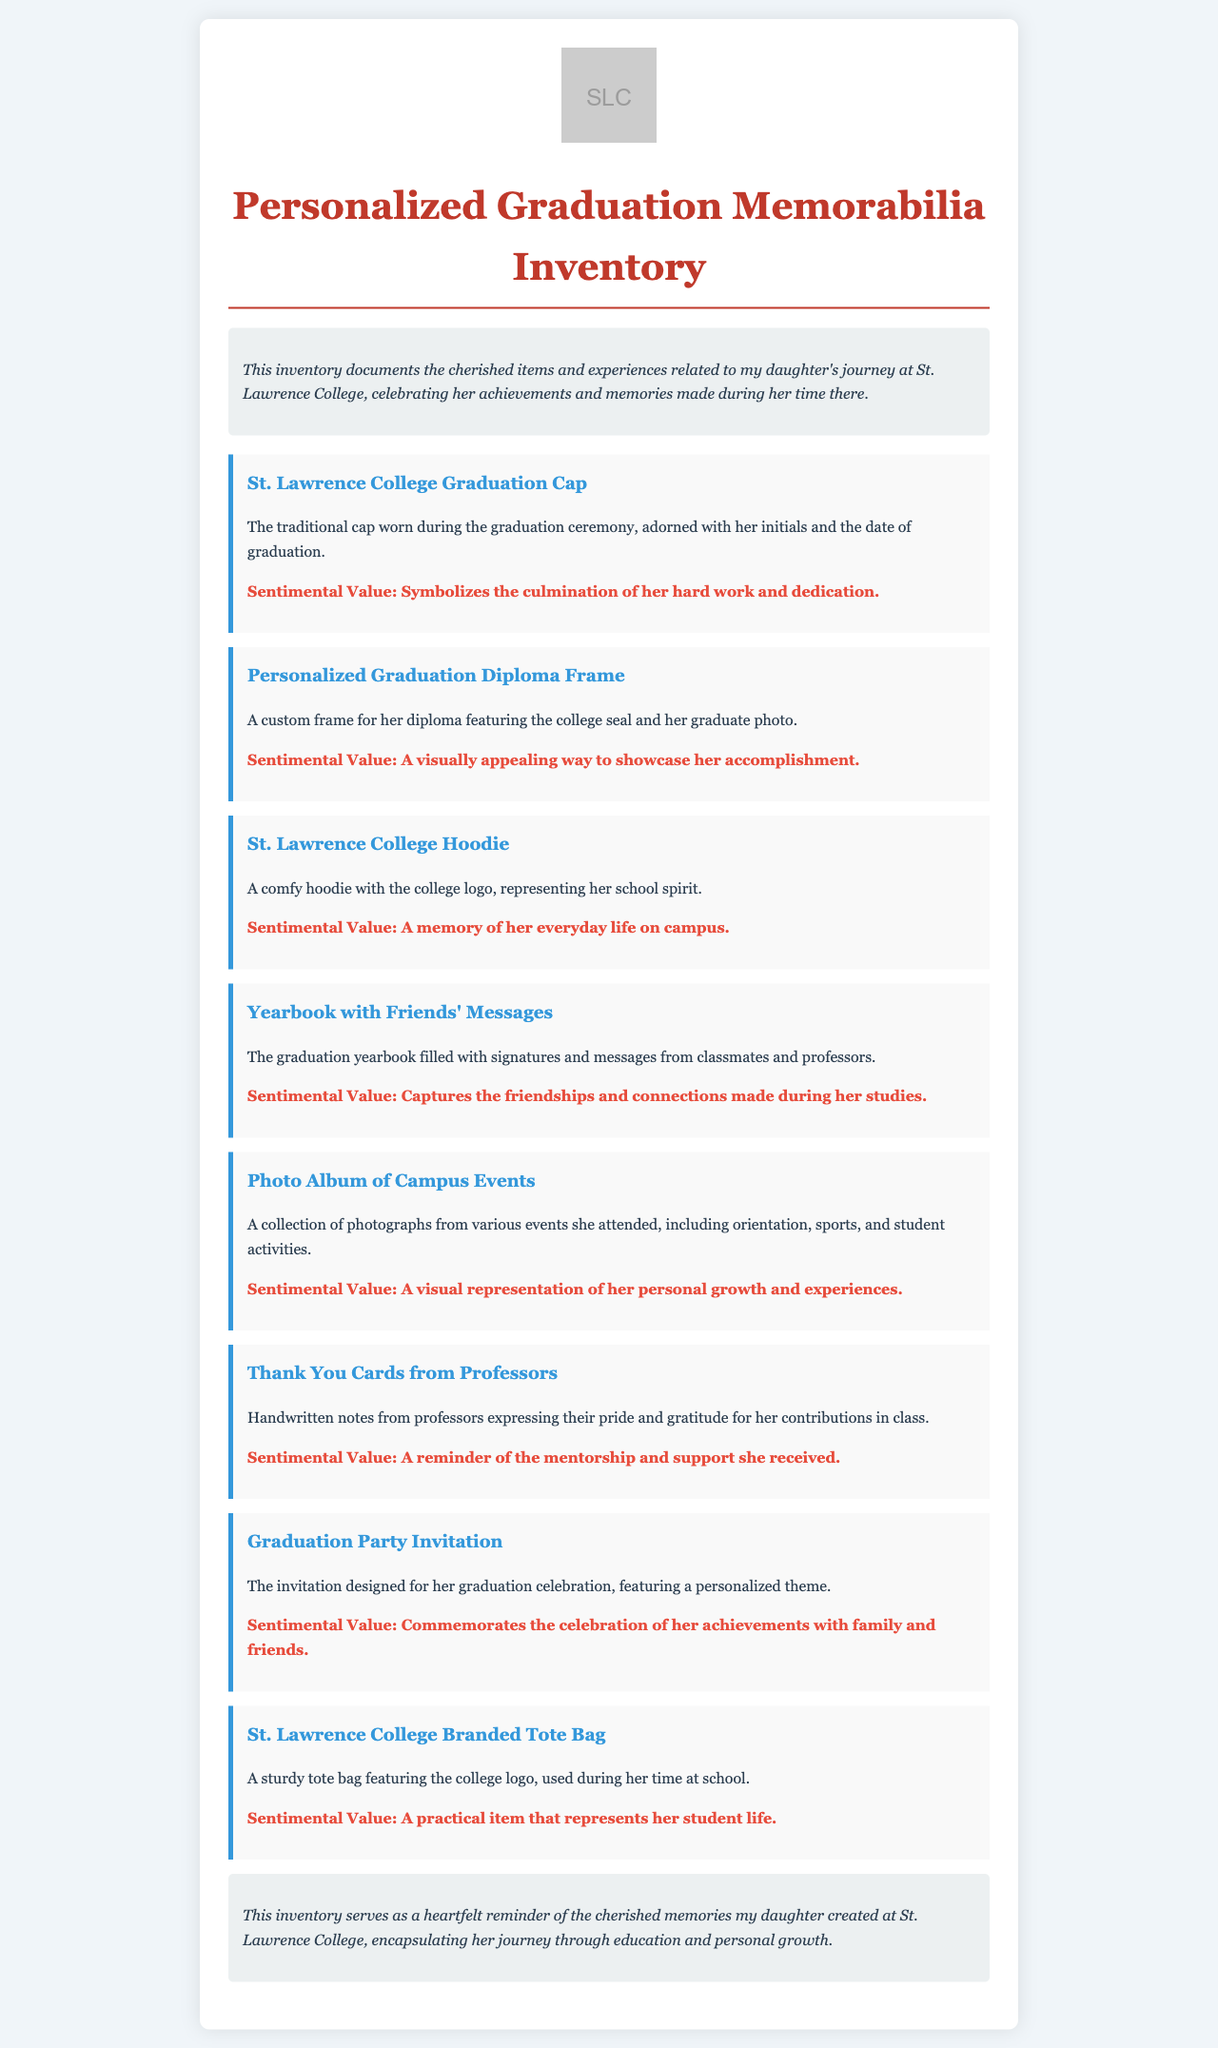what is the title of the document? The title of the document is prominently displayed at the top.
Answer: Personalized Graduation Memorabilia Inventory how many items are listed in the inventory? The document lists all items under the inventory section, which are counted directly.
Answer: 8 what does the graduation cap symbolize? The symbolism of the graduation cap is indicated in its description.
Answer: The culmination of her hard work and dedication what type of item is the personalized graduation diploma frame? The item is defined in the inventory, indicating its nature.
Answer: A custom frame for her diploma which item contains friends' messages? The document specifies the type of memorabilia that contains these messages.
Answer: Yearbook what does the photo album represent? The description of the photo album explains its significance.
Answer: A visual representation of her personal growth and experiences which item celebrates the graduation achievement? The inventory includes items celebrating her achievements, one of which is identified clearly.
Answer: Graduation Party Invitation what color is the college logo featured in the document? The presence of the college logo's color can be inferred from the visual cues described.
Answer: Not specified 